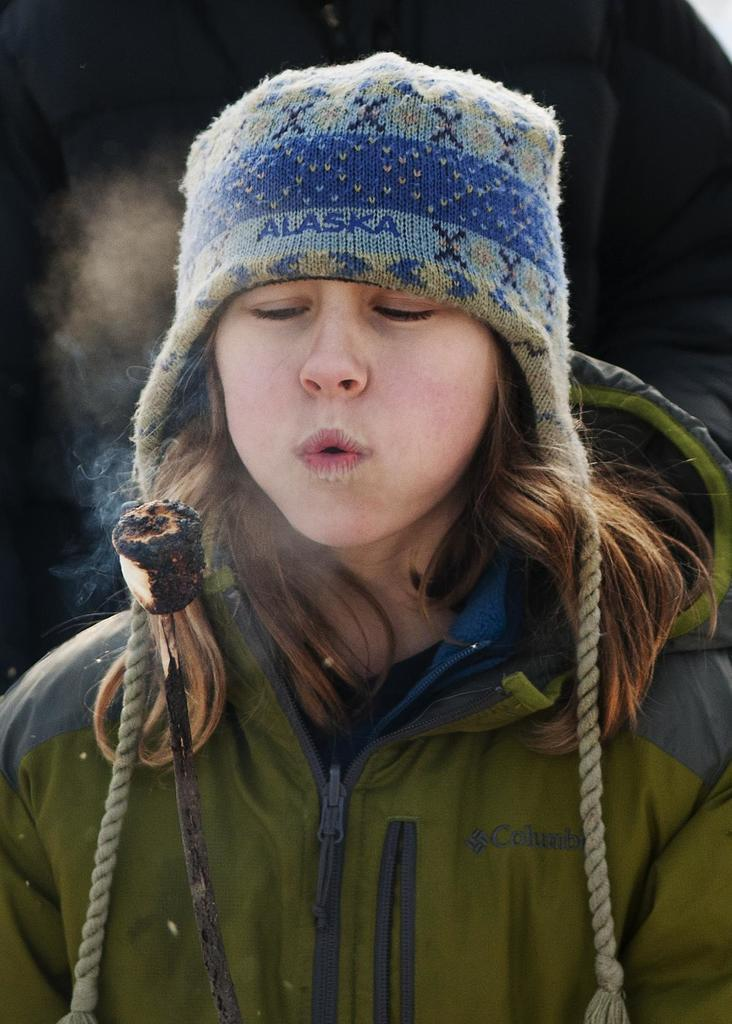Who is the main subject in the image? There is a woman in the image. What is the woman wearing on her upper body? The woman is wearing a green jacket. What type of headwear is the woman wearing? The woman is wearing a cap. What action is the woman performing in the image? The woman is blowing something with her mouth. How would you describe the background of the image? The background of the image is dark in color. What type of sofa is visible in the image? There is no sofa present in the image. What achievements has the woman been recognized for in the image? The image does not provide any information about the woman's achievements or recognition. 